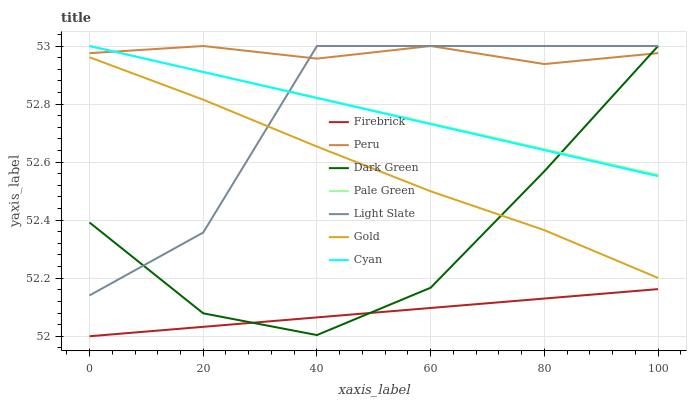Does Firebrick have the minimum area under the curve?
Answer yes or no. Yes. Does Peru have the maximum area under the curve?
Answer yes or no. Yes. Does Light Slate have the minimum area under the curve?
Answer yes or no. No. Does Light Slate have the maximum area under the curve?
Answer yes or no. No. Is Cyan the smoothest?
Answer yes or no. Yes. Is Light Slate the roughest?
Answer yes or no. Yes. Is Firebrick the smoothest?
Answer yes or no. No. Is Firebrick the roughest?
Answer yes or no. No. Does Firebrick have the lowest value?
Answer yes or no. Yes. Does Light Slate have the lowest value?
Answer yes or no. No. Does Dark Green have the highest value?
Answer yes or no. Yes. Does Firebrick have the highest value?
Answer yes or no. No. Is Firebrick less than Cyan?
Answer yes or no. Yes. Is Light Slate greater than Firebrick?
Answer yes or no. Yes. Does Peru intersect Dark Green?
Answer yes or no. Yes. Is Peru less than Dark Green?
Answer yes or no. No. Is Peru greater than Dark Green?
Answer yes or no. No. Does Firebrick intersect Cyan?
Answer yes or no. No. 